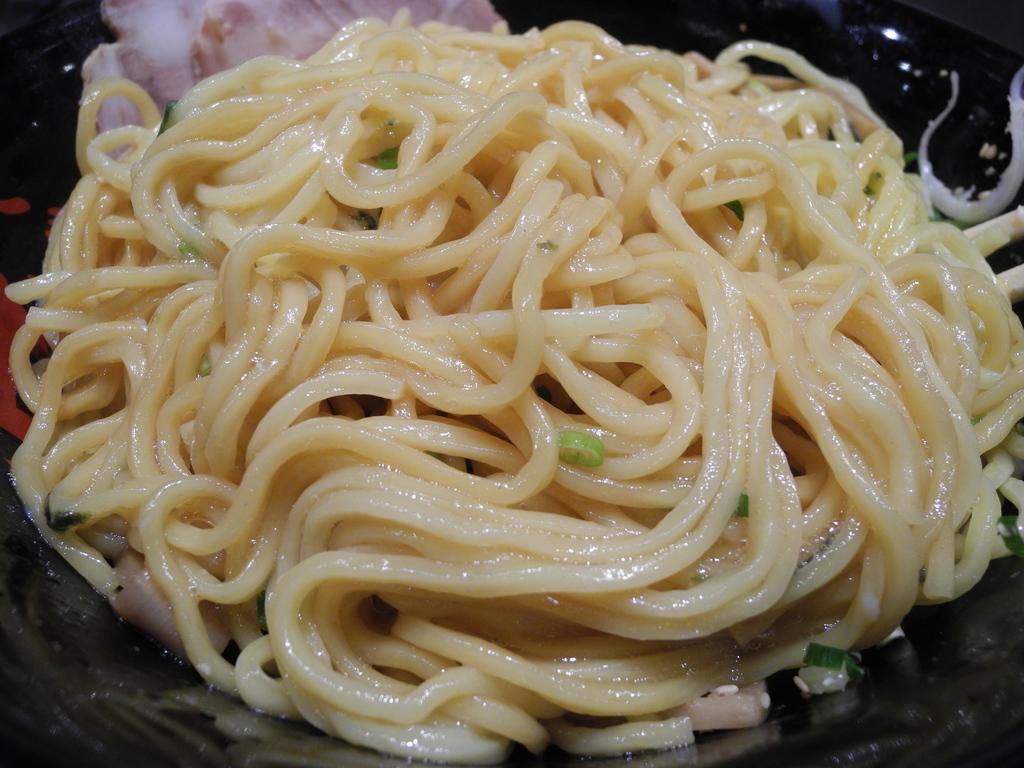In one or two sentences, can you explain what this image depicts? In this image we can see a group of noodles placed in a bowl. In the background, we can see some meat. 